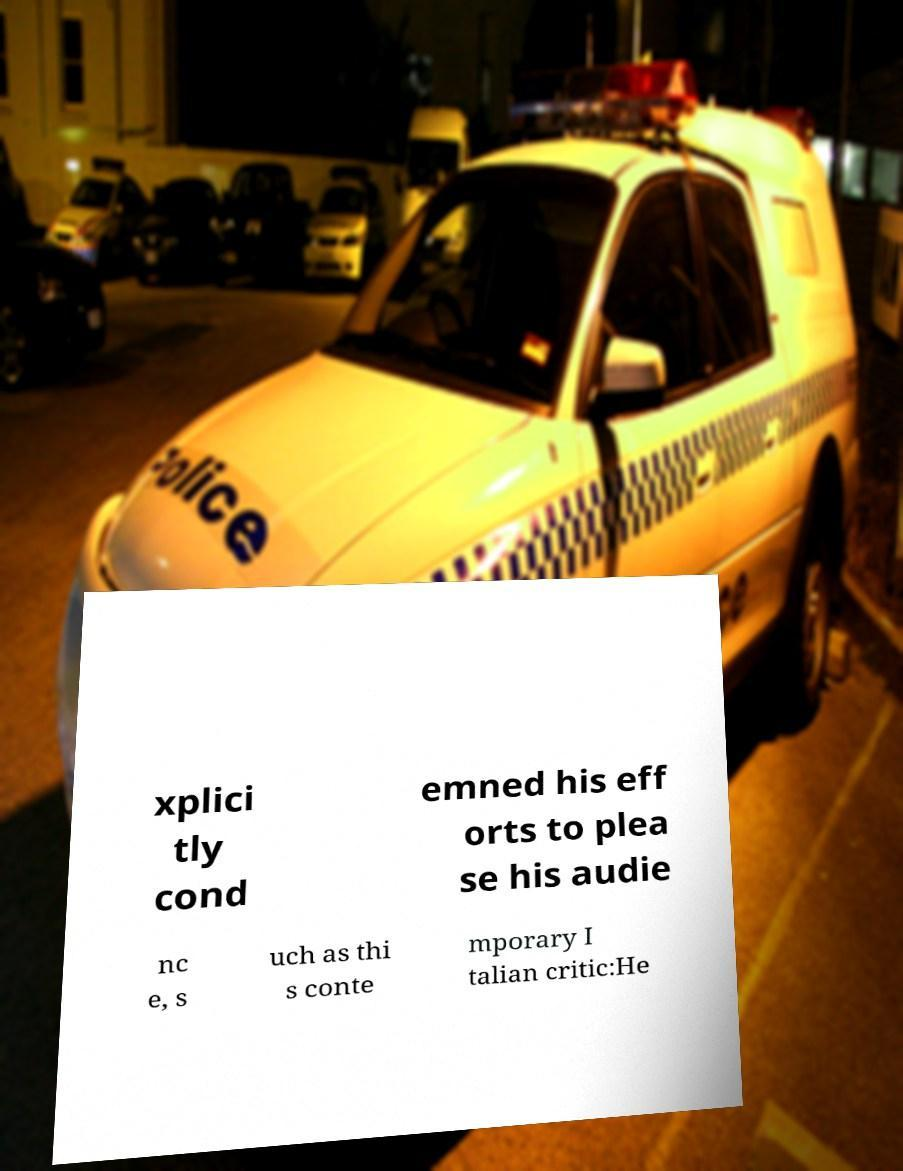For documentation purposes, I need the text within this image transcribed. Could you provide that? xplici tly cond emned his eff orts to plea se his audie nc e, s uch as thi s conte mporary I talian critic:He 